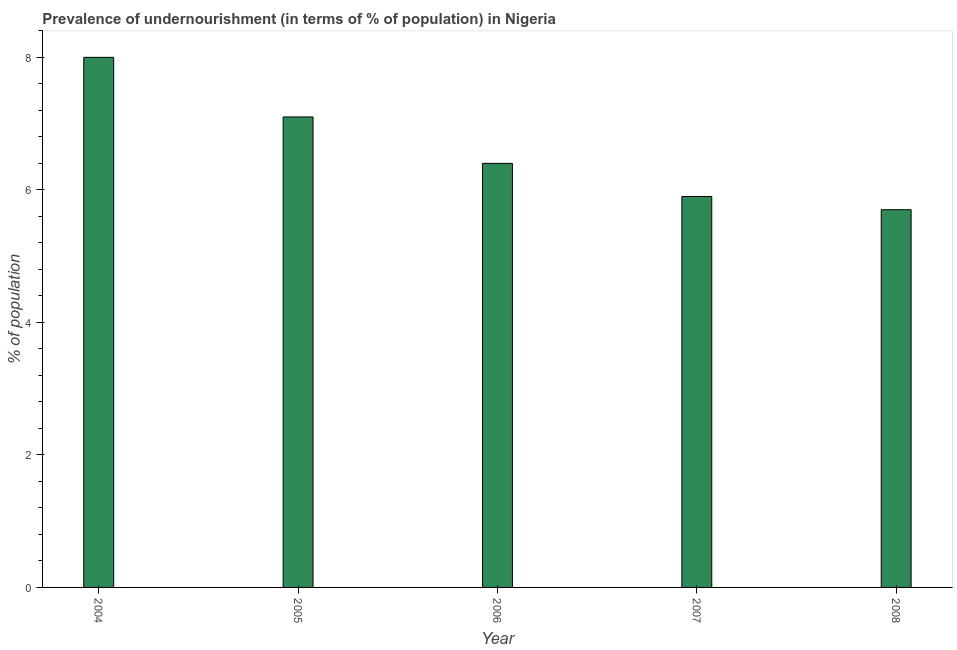Does the graph contain grids?
Offer a terse response. No. What is the title of the graph?
Give a very brief answer. Prevalence of undernourishment (in terms of % of population) in Nigeria. What is the label or title of the Y-axis?
Provide a short and direct response. % of population. What is the percentage of undernourished population in 2004?
Provide a short and direct response. 8. In which year was the percentage of undernourished population maximum?
Provide a short and direct response. 2004. In which year was the percentage of undernourished population minimum?
Your answer should be compact. 2008. What is the sum of the percentage of undernourished population?
Offer a very short reply. 33.1. What is the difference between the percentage of undernourished population in 2006 and 2008?
Your response must be concise. 0.7. What is the average percentage of undernourished population per year?
Your answer should be very brief. 6.62. What is the median percentage of undernourished population?
Give a very brief answer. 6.4. What is the ratio of the percentage of undernourished population in 2004 to that in 2007?
Your answer should be very brief. 1.36. Is the percentage of undernourished population in 2005 less than that in 2007?
Provide a short and direct response. No. Is the sum of the percentage of undernourished population in 2004 and 2006 greater than the maximum percentage of undernourished population across all years?
Make the answer very short. Yes. Are all the bars in the graph horizontal?
Provide a succinct answer. No. How many years are there in the graph?
Make the answer very short. 5. What is the % of population of 2004?
Make the answer very short. 8. What is the % of population in 2005?
Ensure brevity in your answer.  7.1. What is the % of population in 2006?
Make the answer very short. 6.4. What is the % of population in 2007?
Provide a short and direct response. 5.9. What is the % of population of 2008?
Provide a succinct answer. 5.7. What is the difference between the % of population in 2004 and 2005?
Keep it short and to the point. 0.9. What is the difference between the % of population in 2004 and 2006?
Give a very brief answer. 1.6. What is the difference between the % of population in 2004 and 2007?
Make the answer very short. 2.1. What is the difference between the % of population in 2005 and 2007?
Your answer should be very brief. 1.2. What is the difference between the % of population in 2006 and 2007?
Offer a terse response. 0.5. What is the difference between the % of population in 2007 and 2008?
Your answer should be very brief. 0.2. What is the ratio of the % of population in 2004 to that in 2005?
Your answer should be very brief. 1.13. What is the ratio of the % of population in 2004 to that in 2006?
Your answer should be compact. 1.25. What is the ratio of the % of population in 2004 to that in 2007?
Provide a short and direct response. 1.36. What is the ratio of the % of population in 2004 to that in 2008?
Provide a succinct answer. 1.4. What is the ratio of the % of population in 2005 to that in 2006?
Provide a succinct answer. 1.11. What is the ratio of the % of population in 2005 to that in 2007?
Provide a succinct answer. 1.2. What is the ratio of the % of population in 2005 to that in 2008?
Your response must be concise. 1.25. What is the ratio of the % of population in 2006 to that in 2007?
Provide a short and direct response. 1.08. What is the ratio of the % of population in 2006 to that in 2008?
Make the answer very short. 1.12. What is the ratio of the % of population in 2007 to that in 2008?
Ensure brevity in your answer.  1.03. 